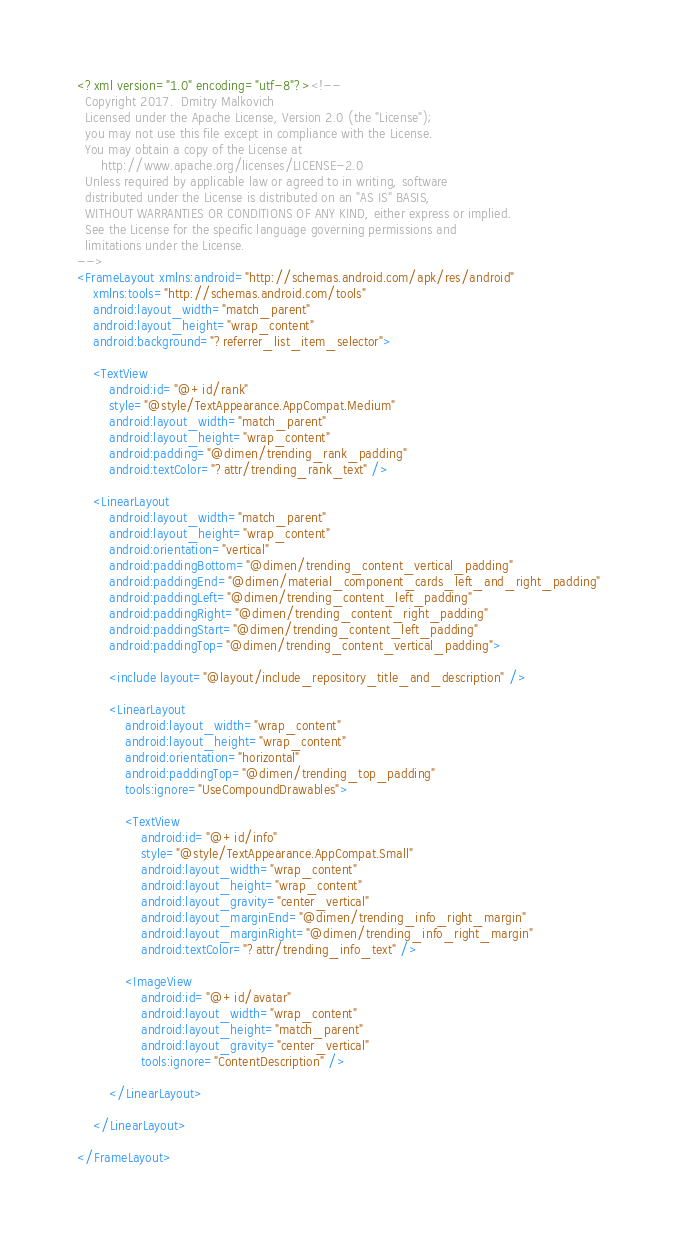Convert code to text. <code><loc_0><loc_0><loc_500><loc_500><_XML_><?xml version="1.0" encoding="utf-8"?><!--
  Copyright 2017.  Dmitry Malkovich
  Licensed under the Apache License, Version 2.0 (the "License");
  you may not use this file except in compliance with the License.
  You may obtain a copy of the License at
      http://www.apache.org/licenses/LICENSE-2.0
  Unless required by applicable law or agreed to in writing, software
  distributed under the License is distributed on an "AS IS" BASIS,
  WITHOUT WARRANTIES OR CONDITIONS OF ANY KIND, either express or implied.
  See the License for the specific language governing permissions and
  limitations under the License.
-->
<FrameLayout xmlns:android="http://schemas.android.com/apk/res/android"
    xmlns:tools="http://schemas.android.com/tools"
    android:layout_width="match_parent"
    android:layout_height="wrap_content"
    android:background="?referrer_list_item_selector">

    <TextView
        android:id="@+id/rank"
        style="@style/TextAppearance.AppCompat.Medium"
        android:layout_width="match_parent"
        android:layout_height="wrap_content"
        android:padding="@dimen/trending_rank_padding"
        android:textColor="?attr/trending_rank_text" />

    <LinearLayout
        android:layout_width="match_parent"
        android:layout_height="wrap_content"
        android:orientation="vertical"
        android:paddingBottom="@dimen/trending_content_vertical_padding"
        android:paddingEnd="@dimen/material_component_cards_left_and_right_padding"
        android:paddingLeft="@dimen/trending_content_left_padding"
        android:paddingRight="@dimen/trending_content_right_padding"
        android:paddingStart="@dimen/trending_content_left_padding"
        android:paddingTop="@dimen/trending_content_vertical_padding">

        <include layout="@layout/include_repository_title_and_description" />

        <LinearLayout
            android:layout_width="wrap_content"
            android:layout_height="wrap_content"
            android:orientation="horizontal"
            android:paddingTop="@dimen/trending_top_padding"
            tools:ignore="UseCompoundDrawables">

            <TextView
                android:id="@+id/info"
                style="@style/TextAppearance.AppCompat.Small"
                android:layout_width="wrap_content"
                android:layout_height="wrap_content"
                android:layout_gravity="center_vertical"
                android:layout_marginEnd="@dimen/trending_info_right_margin"
                android:layout_marginRight="@dimen/trending_info_right_margin"
                android:textColor="?attr/trending_info_text" />

            <ImageView
                android:id="@+id/avatar"
                android:layout_width="wrap_content"
                android:layout_height="match_parent"
                android:layout_gravity="center_vertical"
                tools:ignore="ContentDescription" />

        </LinearLayout>

    </LinearLayout>

</FrameLayout></code> 